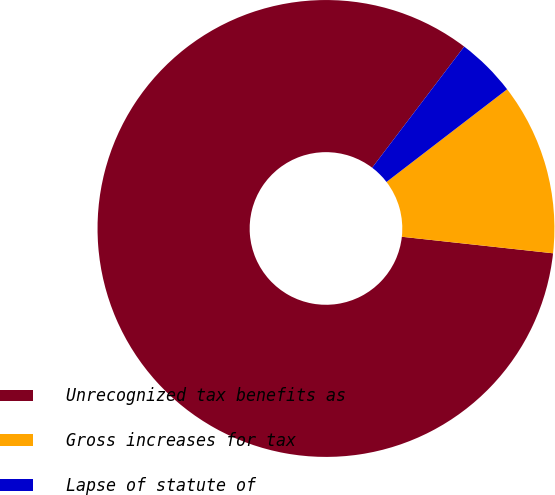Convert chart to OTSL. <chart><loc_0><loc_0><loc_500><loc_500><pie_chart><fcel>Unrecognized tax benefits as<fcel>Gross increases for tax<fcel>Lapse of statute of<nl><fcel>83.61%<fcel>12.16%<fcel>4.23%<nl></chart> 